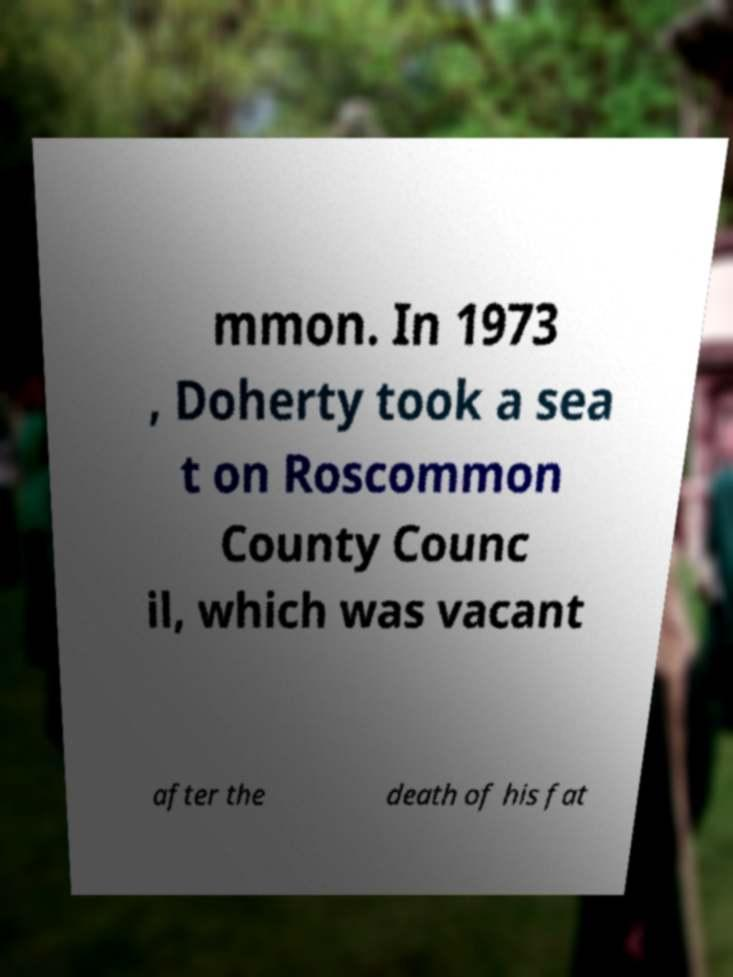For documentation purposes, I need the text within this image transcribed. Could you provide that? mmon. In 1973 , Doherty took a sea t on Roscommon County Counc il, which was vacant after the death of his fat 